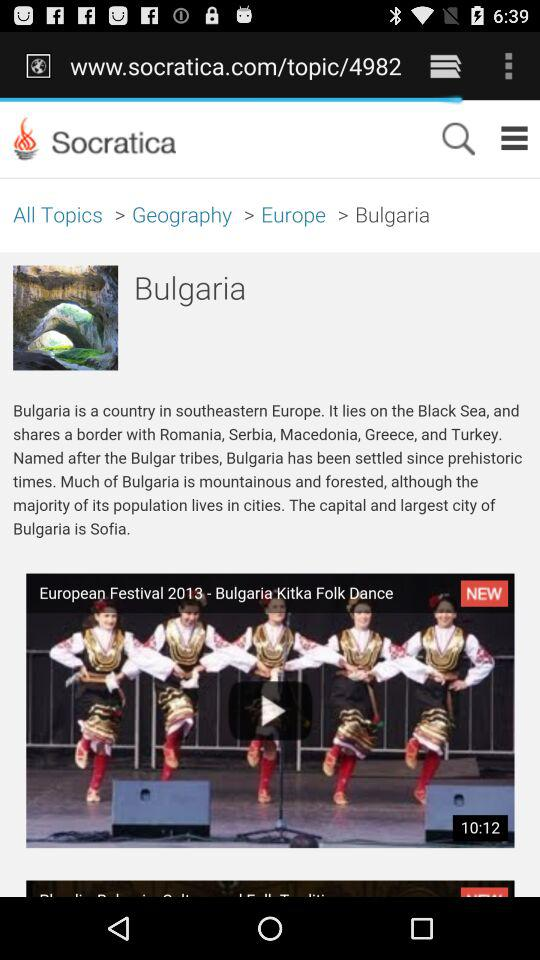What is Bulgaria? Bulgaria is a country in southeastern Europe. 